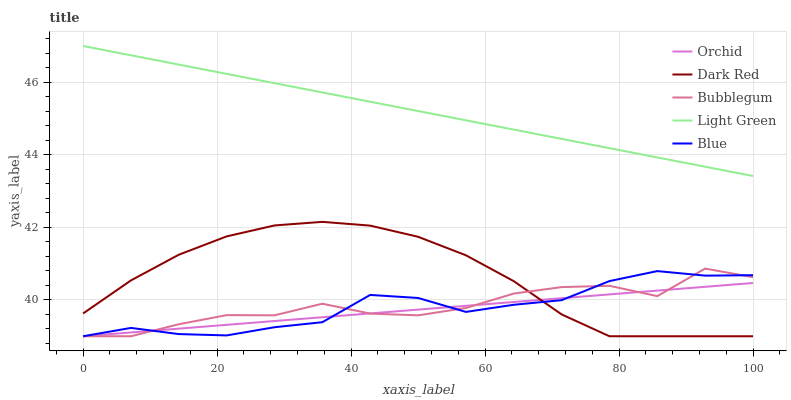Does Orchid have the minimum area under the curve?
Answer yes or no. Yes. Does Light Green have the maximum area under the curve?
Answer yes or no. Yes. Does Dark Red have the minimum area under the curve?
Answer yes or no. No. Does Dark Red have the maximum area under the curve?
Answer yes or no. No. Is Light Green the smoothest?
Answer yes or no. Yes. Is Bubblegum the roughest?
Answer yes or no. Yes. Is Dark Red the smoothest?
Answer yes or no. No. Is Dark Red the roughest?
Answer yes or no. No. Does Blue have the lowest value?
Answer yes or no. Yes. Does Light Green have the lowest value?
Answer yes or no. No. Does Light Green have the highest value?
Answer yes or no. Yes. Does Dark Red have the highest value?
Answer yes or no. No. Is Bubblegum less than Light Green?
Answer yes or no. Yes. Is Light Green greater than Blue?
Answer yes or no. Yes. Does Dark Red intersect Bubblegum?
Answer yes or no. Yes. Is Dark Red less than Bubblegum?
Answer yes or no. No. Is Dark Red greater than Bubblegum?
Answer yes or no. No. Does Bubblegum intersect Light Green?
Answer yes or no. No. 